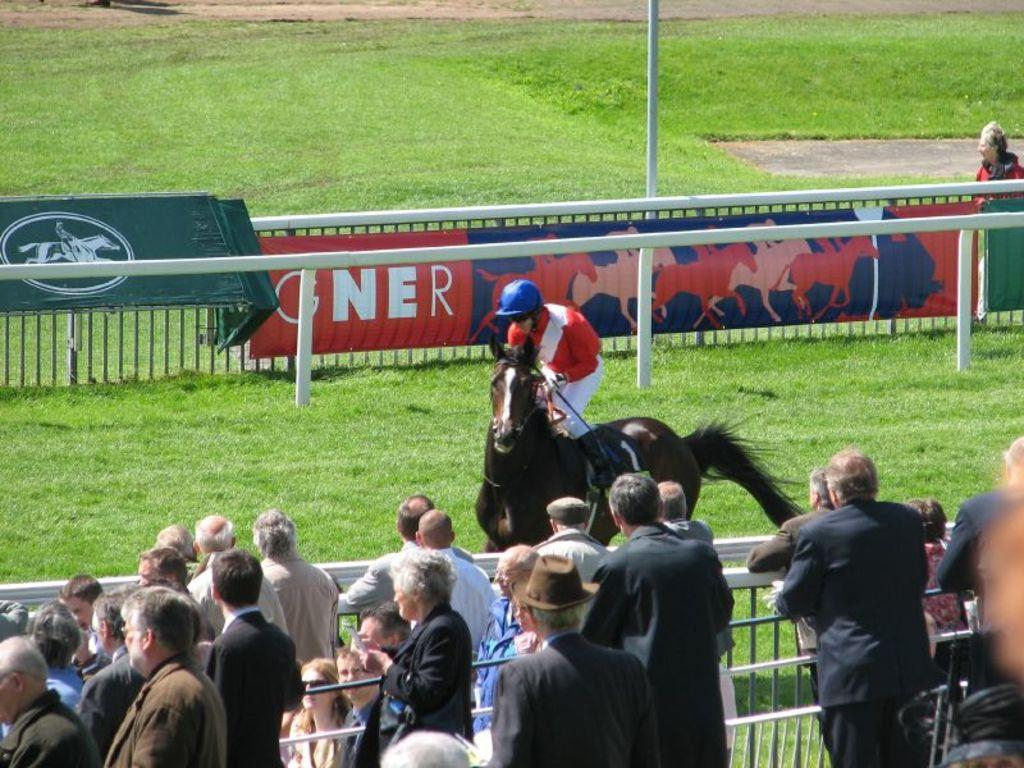How many people are in the image? There is a group of people standing in the image. What is one person in the image doing? There is a person riding a horse in the image. What safety equipment is the person riding the horse wearing? The person riding the horse is wearing a helmet. What decorative elements can be seen in the image? There are banners in the image. What type of barrier is present in the image? There is a fence in the image. What vertical structure can be seen in the image? There is a pole in the image. What type of ground surface is visible in the image? There is grass visible in the image. What religion is being practiced by the group of people in the image? There is no information about religion in the image; it only shows a group of people, a person riding a horse, banners, a fence, a pole, and grass. What day of the week is it in the image? The day of the week cannot be determined from the image; it only shows a group of people, a person riding a horse, banners, a fence, a pole, and grass. 